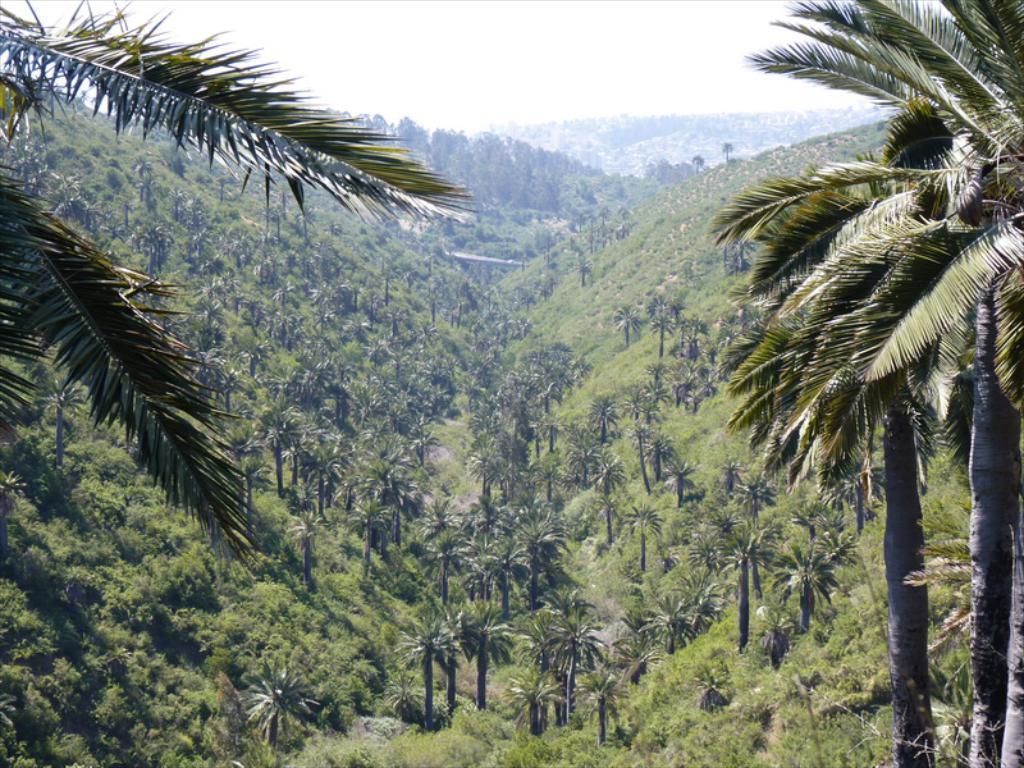Please provide a concise description of this image. In this image we can see few trees, plants, mountains and the sky. 